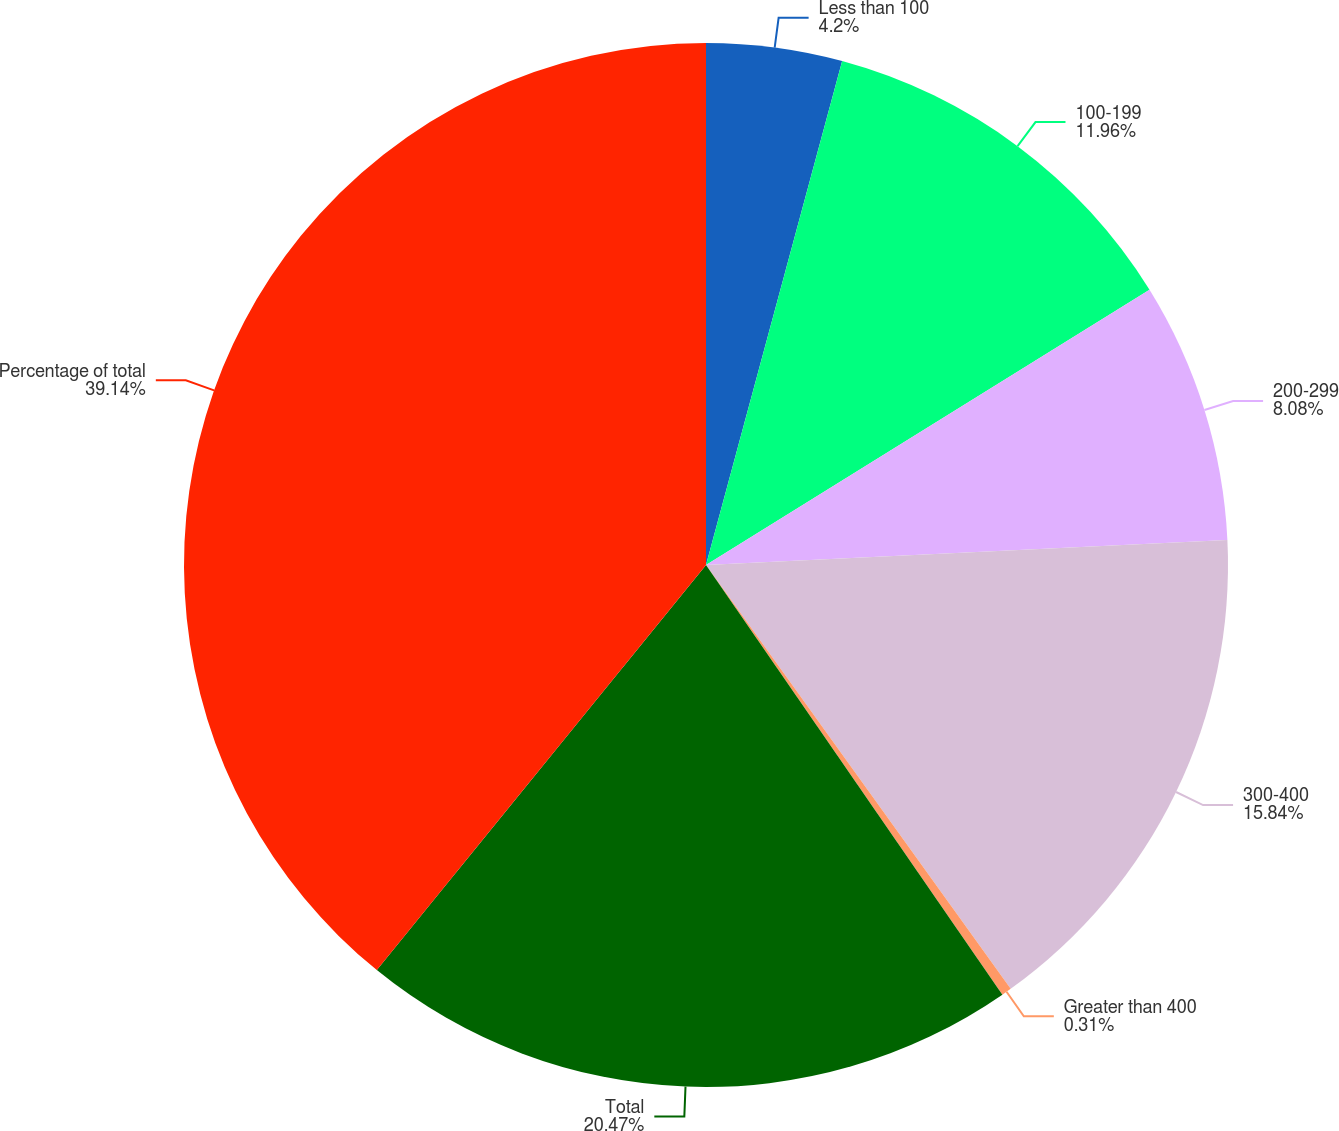Convert chart. <chart><loc_0><loc_0><loc_500><loc_500><pie_chart><fcel>Less than 100<fcel>100-199<fcel>200-299<fcel>300-400<fcel>Greater than 400<fcel>Total<fcel>Percentage of total<nl><fcel>4.2%<fcel>11.96%<fcel>8.08%<fcel>15.84%<fcel>0.31%<fcel>20.47%<fcel>39.14%<nl></chart> 